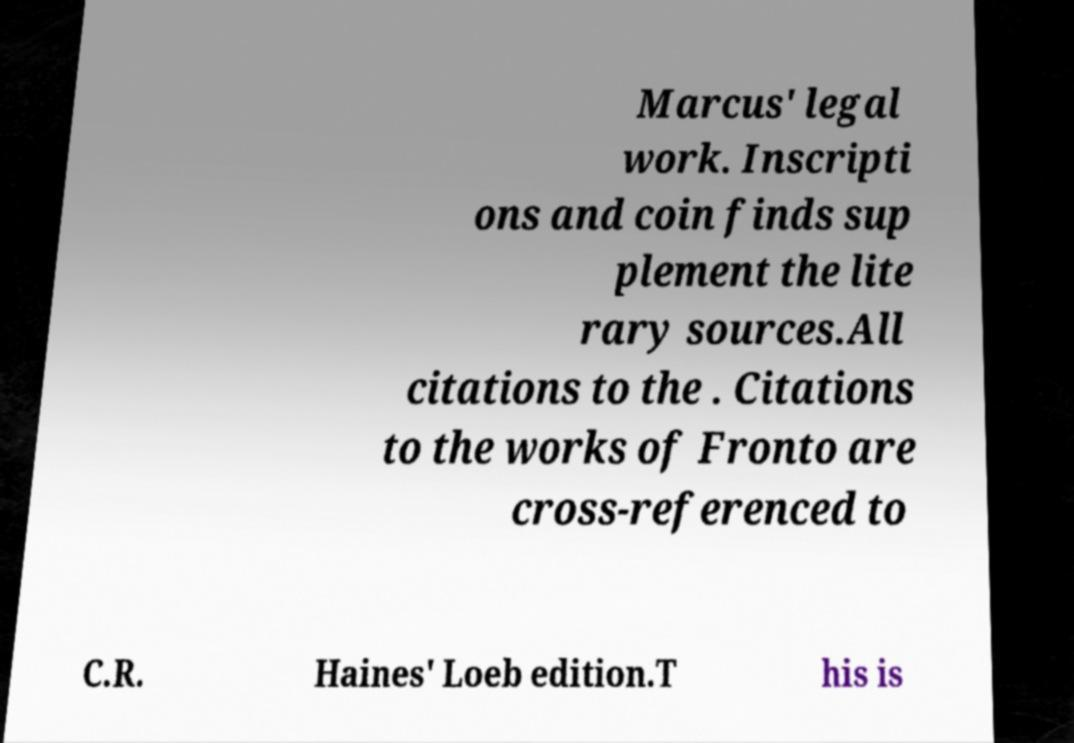Please identify and transcribe the text found in this image. Marcus' legal work. Inscripti ons and coin finds sup plement the lite rary sources.All citations to the . Citations to the works of Fronto are cross-referenced to C.R. Haines' Loeb edition.T his is 